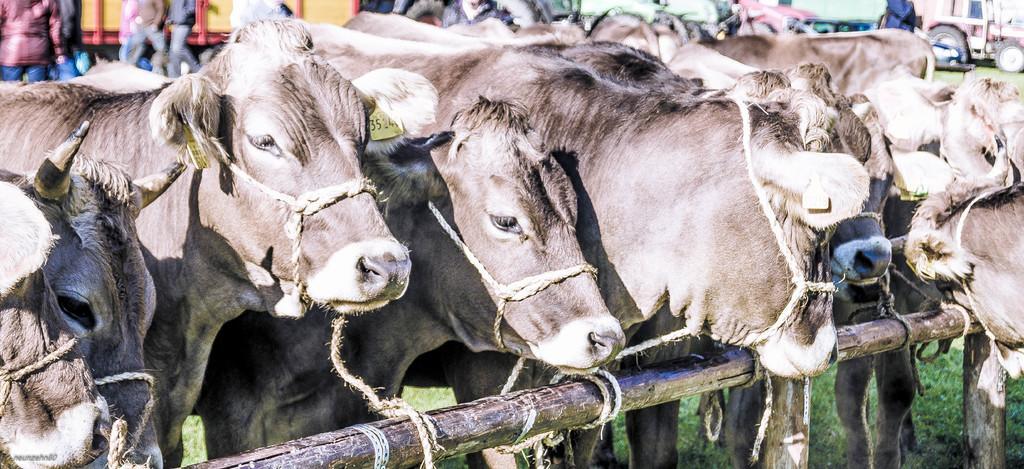How would you summarize this image in a sentence or two? In the center of the image there are cows tied to a bamboo stick. In the bottom of the image there is grass. 